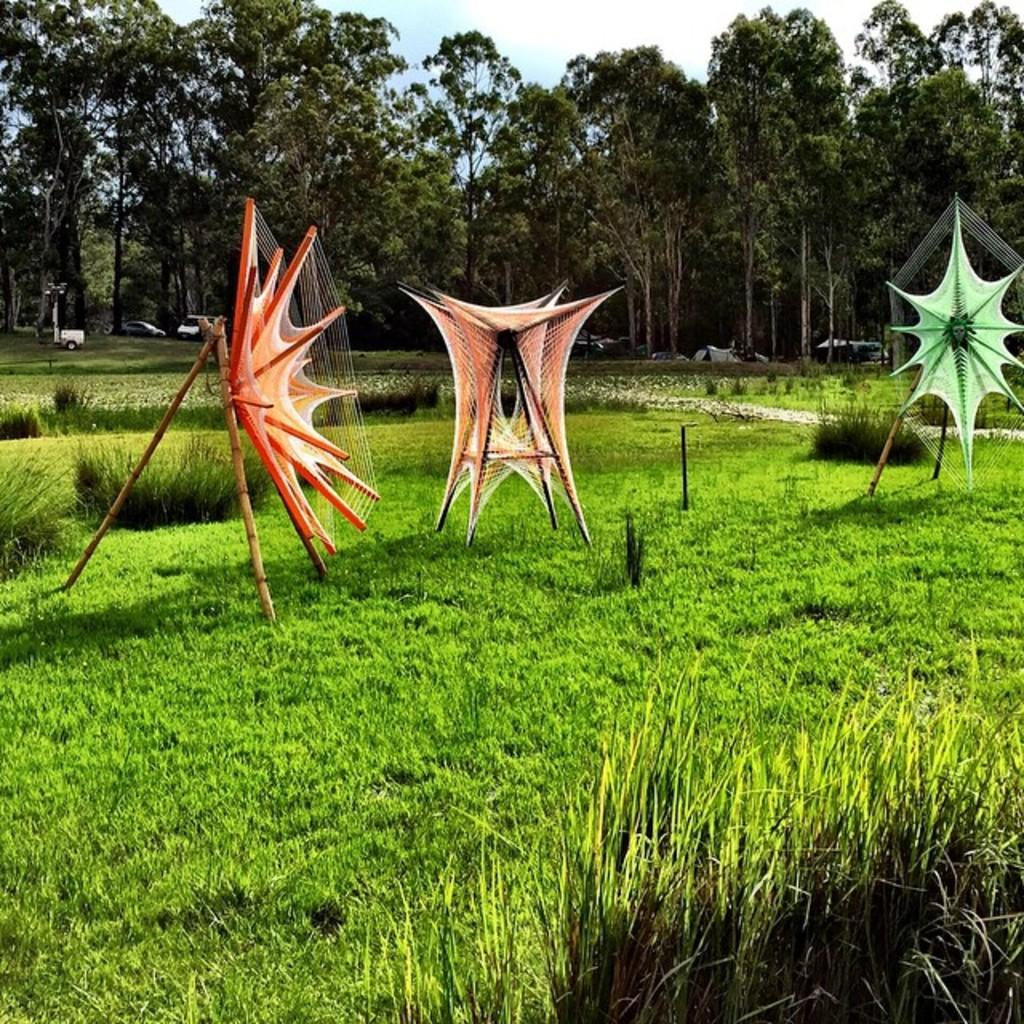What type of vegetation is present in the image? There is grass in the image. What can be seen in the background of the image? There are vehicles and trees in the background of the image. What part of the natural environment is visible in the image? The sky is visible in the background of the image. How many cows are grazing on the grass in the image? There are no cows present in the image; it only features grass, vehicles, trees, and the sky. 